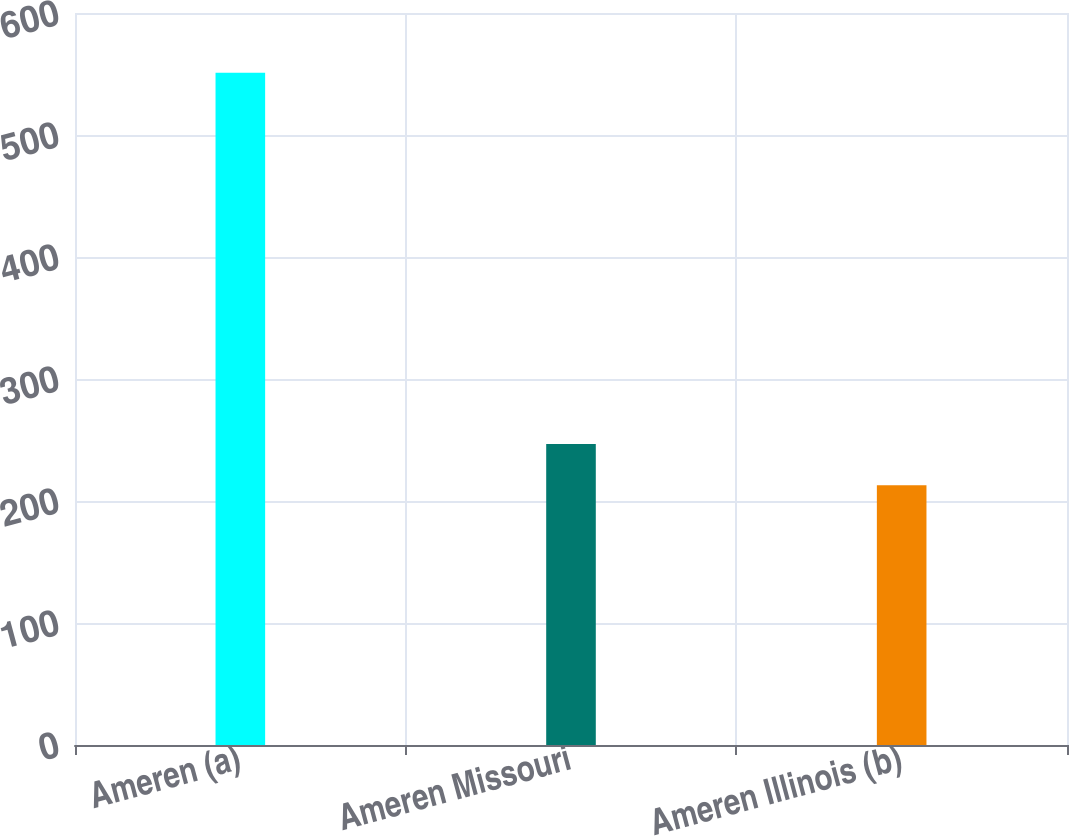<chart> <loc_0><loc_0><loc_500><loc_500><bar_chart><fcel>Ameren (a)<fcel>Ameren Missouri<fcel>Ameren Illinois (b)<nl><fcel>551<fcel>246.8<fcel>213<nl></chart> 